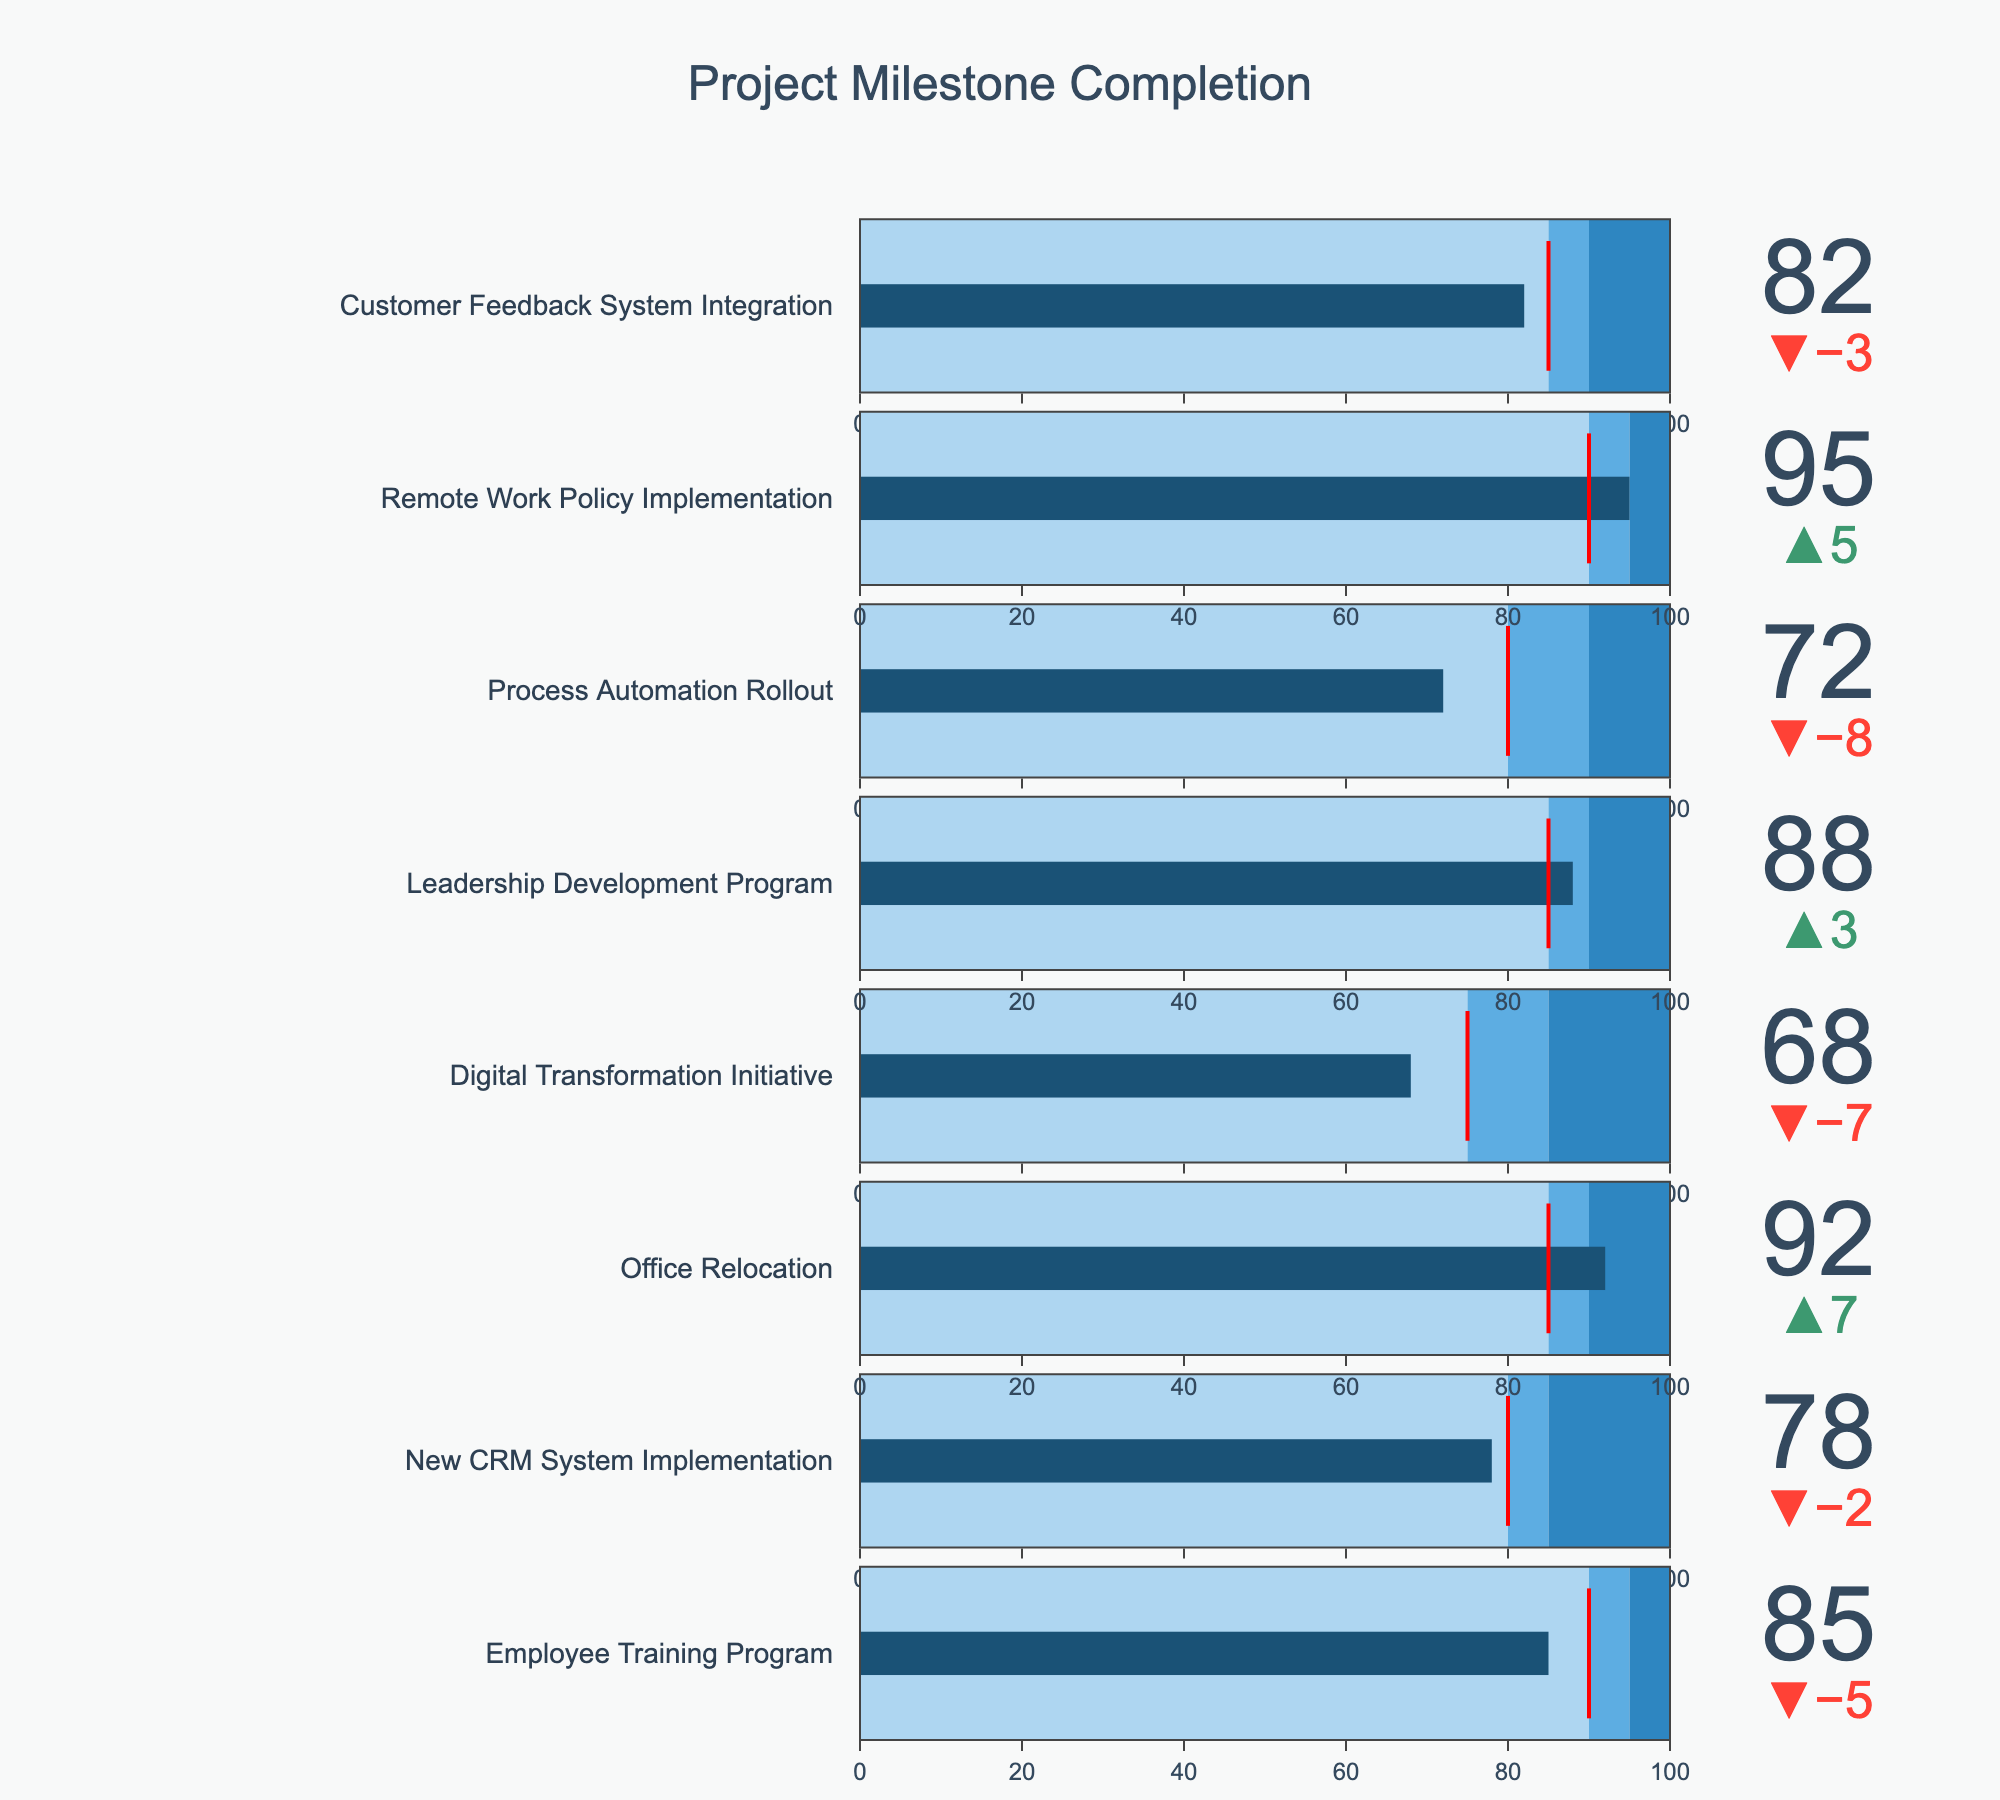What is the title of the figure? The title of the figure is displayed prominently at the top of the chart. By directly reading the figure, we can see the title.
Answer: Project Milestone Completion How many projects have an actual completion percentage above their target? To determine this, we observe each project’s actual completion percentage compared to the set target. Those with a higher actual completion percentage are counted. Employee Training Program (85% vs 90%), Office Relocation (92% vs 85%), Leadership Development Program (88% vs 85%), and Remote Work Policy Implementation (95% vs 90%) meet this criterion.
Answer: 4 Which project has the lowest actual completion percentage? To find the project with the lowest actual completion percentage, scan through the values from the bottom up. The Digital Transformation Initiative has the lowest percentage at 68%.
Answer: Digital Transformation Initiative By how many percentage points does the Remote Work Policy Implementation exceed its target? The Remote Work Policy Implementation completion percentage (95%) exceeds its target of 90%. Subtract the target from the actual completion percentage to find the difference: 95% - 90% = 5 percentage points.
Answer: 5 Which project shows the largest shortfall compared to its target? Finding the largest shortfall requires calculating the difference between the target and actual completion percentages for each project, then identifying the largest value. The Digital Transformation Initiative falls short by 75% - 68% = 7%.
Answer: Digital Transformation Initiative How many projects have a stretch goal of 90% or higher? To answer this, count the number of projects with a stretch goal value of 90% or more. By scanning the data, we find that Employee Training Program, Office Relocation, Leadership Development Program, Process Automation Rollout, Remote Work Policy Implementation, and Customer Feedback System Integration have stretch goals 90% or more.
Answer: 6 Which project managed to surpass their stretch goal? To determine this, we compare each project's actual completion percentage with their stretch goal. If the actual completion is greater than the stretch goal, it meets the condition. Only the Remote Work Policy Implementation exceeds its stretch goal with an actual completion of 95% against a stretch goal of 95%.
Answer: Remote Work Policy Implementation What is the median actual completion percentage of all projects? To find the median, sort the actual completion percentages in ascending order: 68%, 72%, 78%, 82%, 85%, 88%, 92%, 95%. The middle two values are 82% and 85%, and their average is (82% + 85%) / 2 = 83.5%.
Answer: 83.5 How many projects have an actual completion percentage within their target range but below their stretch goal range? For this, count projects where the actual completion percentage is greater than or equal to the target but less than or equal to the stretch goal. Employee Training Program (85% within 90-95), New CRM System Implementation (78% within 80-85), Office Relocation (92% within 85-90), Leadership Development Program (88% within 85-90), Process Automation Rollout (72% within 80-90), Remote Work Policy Implementation (95% within 90-95), and Customer Feedback System Integration (82% within 85-90) meet this criterion.
Answer: 4 Which project falls short of its target by only 2%? Observe each project's actual completion percentage and its target, looking for a difference of 2%. New CRM System Implementation has an actual completion percentage of 78% against a target of 80%, resulting in a shortfall of 2%.
Answer: New CRM System Implementation 